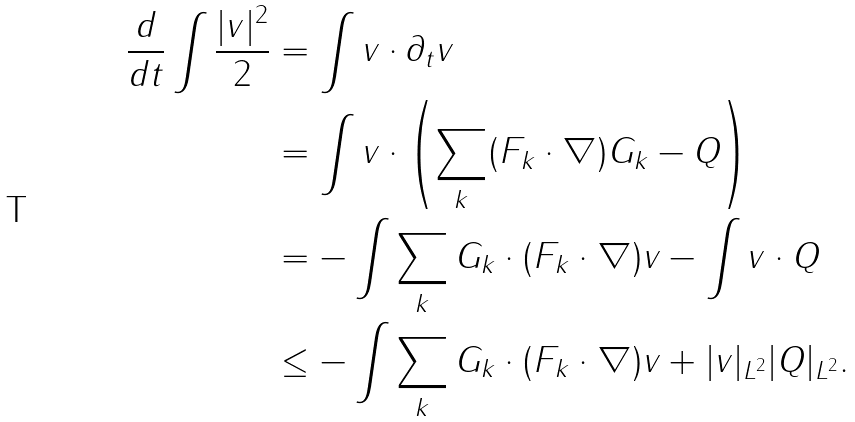Convert formula to latex. <formula><loc_0><loc_0><loc_500><loc_500>\frac { d } { d t } \int \frac { | v | ^ { 2 } } { 2 } & = \int v \cdot \partial _ { t } v \\ & = \int v \cdot \left ( \sum _ { k } ( F _ { k } \cdot \nabla ) G _ { k } - Q \right ) \\ & = - \int \sum _ { k } G _ { k } \cdot ( F _ { k } \cdot \nabla ) v - \int v \cdot Q \\ & \leq - \int \sum _ { k } G _ { k } \cdot ( F _ { k } \cdot \nabla ) v + | v | _ { L ^ { 2 } } | Q | _ { L ^ { 2 } } .</formula> 